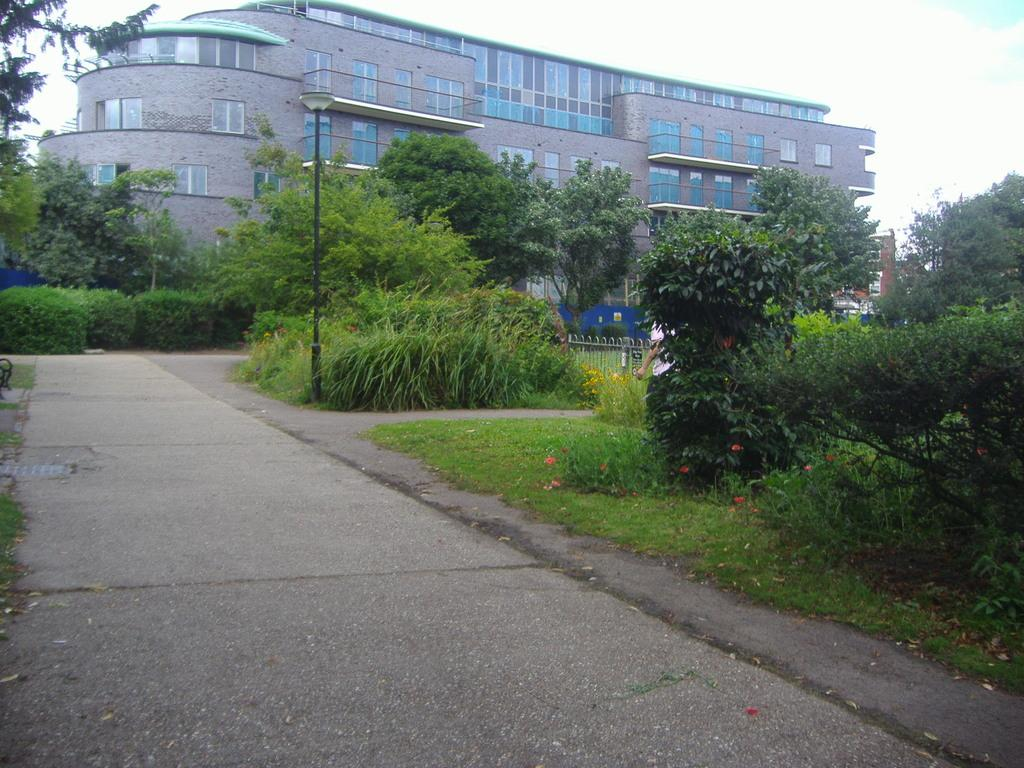What type of vegetation can be seen in the image? There are trees and plants in the image. What is located beside the road in the image? There is a pole beside the road in the image. What structure is visible at the top of the image? There is a building at the top of the image. Can you tell me how many people are performing on the stage in the image? There is no stage present in the image, so it is not possible to determine the number of people performing. 